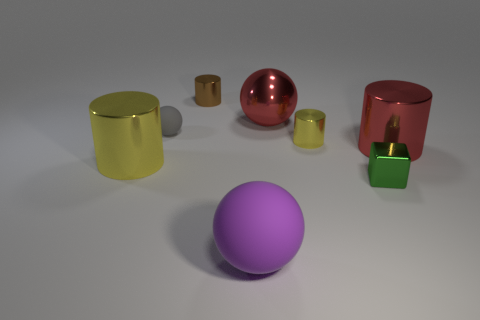Subtract all big spheres. How many spheres are left? 1 Add 1 small cubes. How many objects exist? 9 Subtract all cyan blocks. How many yellow cylinders are left? 2 Add 7 green blocks. How many green blocks are left? 8 Add 7 tiny blocks. How many tiny blocks exist? 8 Subtract all yellow cylinders. How many cylinders are left? 2 Subtract 0 cyan balls. How many objects are left? 8 Subtract all balls. How many objects are left? 5 Subtract 3 balls. How many balls are left? 0 Subtract all gray balls. Subtract all brown cylinders. How many balls are left? 2 